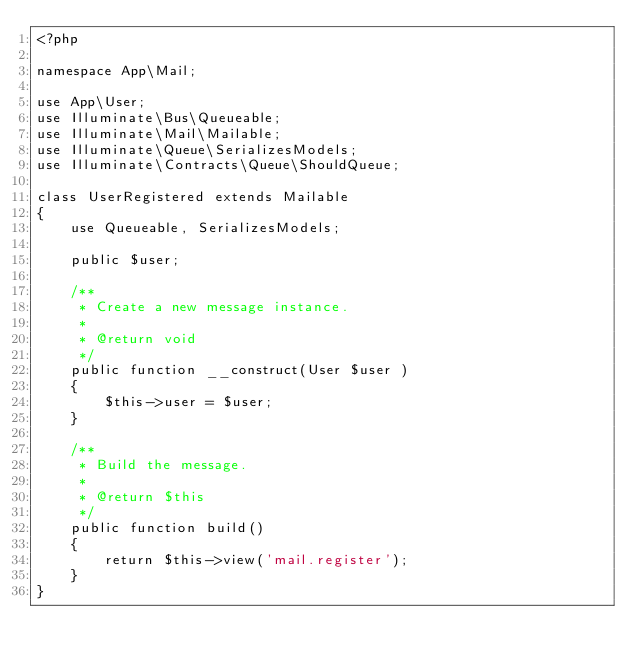Convert code to text. <code><loc_0><loc_0><loc_500><loc_500><_PHP_><?php

namespace App\Mail;

use App\User;
use Illuminate\Bus\Queueable;
use Illuminate\Mail\Mailable;
use Illuminate\Queue\SerializesModels;
use Illuminate\Contracts\Queue\ShouldQueue;

class UserRegistered extends Mailable
{
    use Queueable, SerializesModels;

    public $user;

    /**
     * Create a new message instance.
     *
     * @return void
     */
    public function __construct(User $user )
    {
        $this->user = $user;
    }

    /**
     * Build the message.
     *
     * @return $this
     */
    public function build()
    {
        return $this->view('mail.register');
    }
}
</code> 